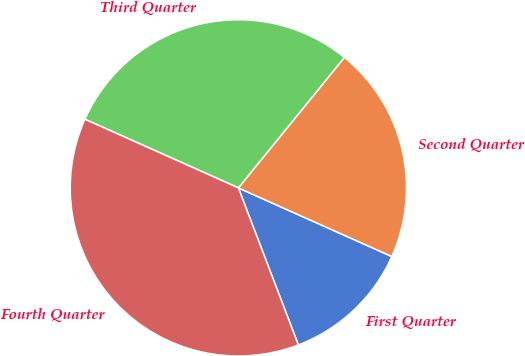Convert chart to OTSL. <chart><loc_0><loc_0><loc_500><loc_500><pie_chart><fcel>First Quarter<fcel>Second Quarter<fcel>Third Quarter<fcel>Fourth Quarter<nl><fcel>12.5%<fcel>20.83%<fcel>29.17%<fcel>37.5%<nl></chart> 